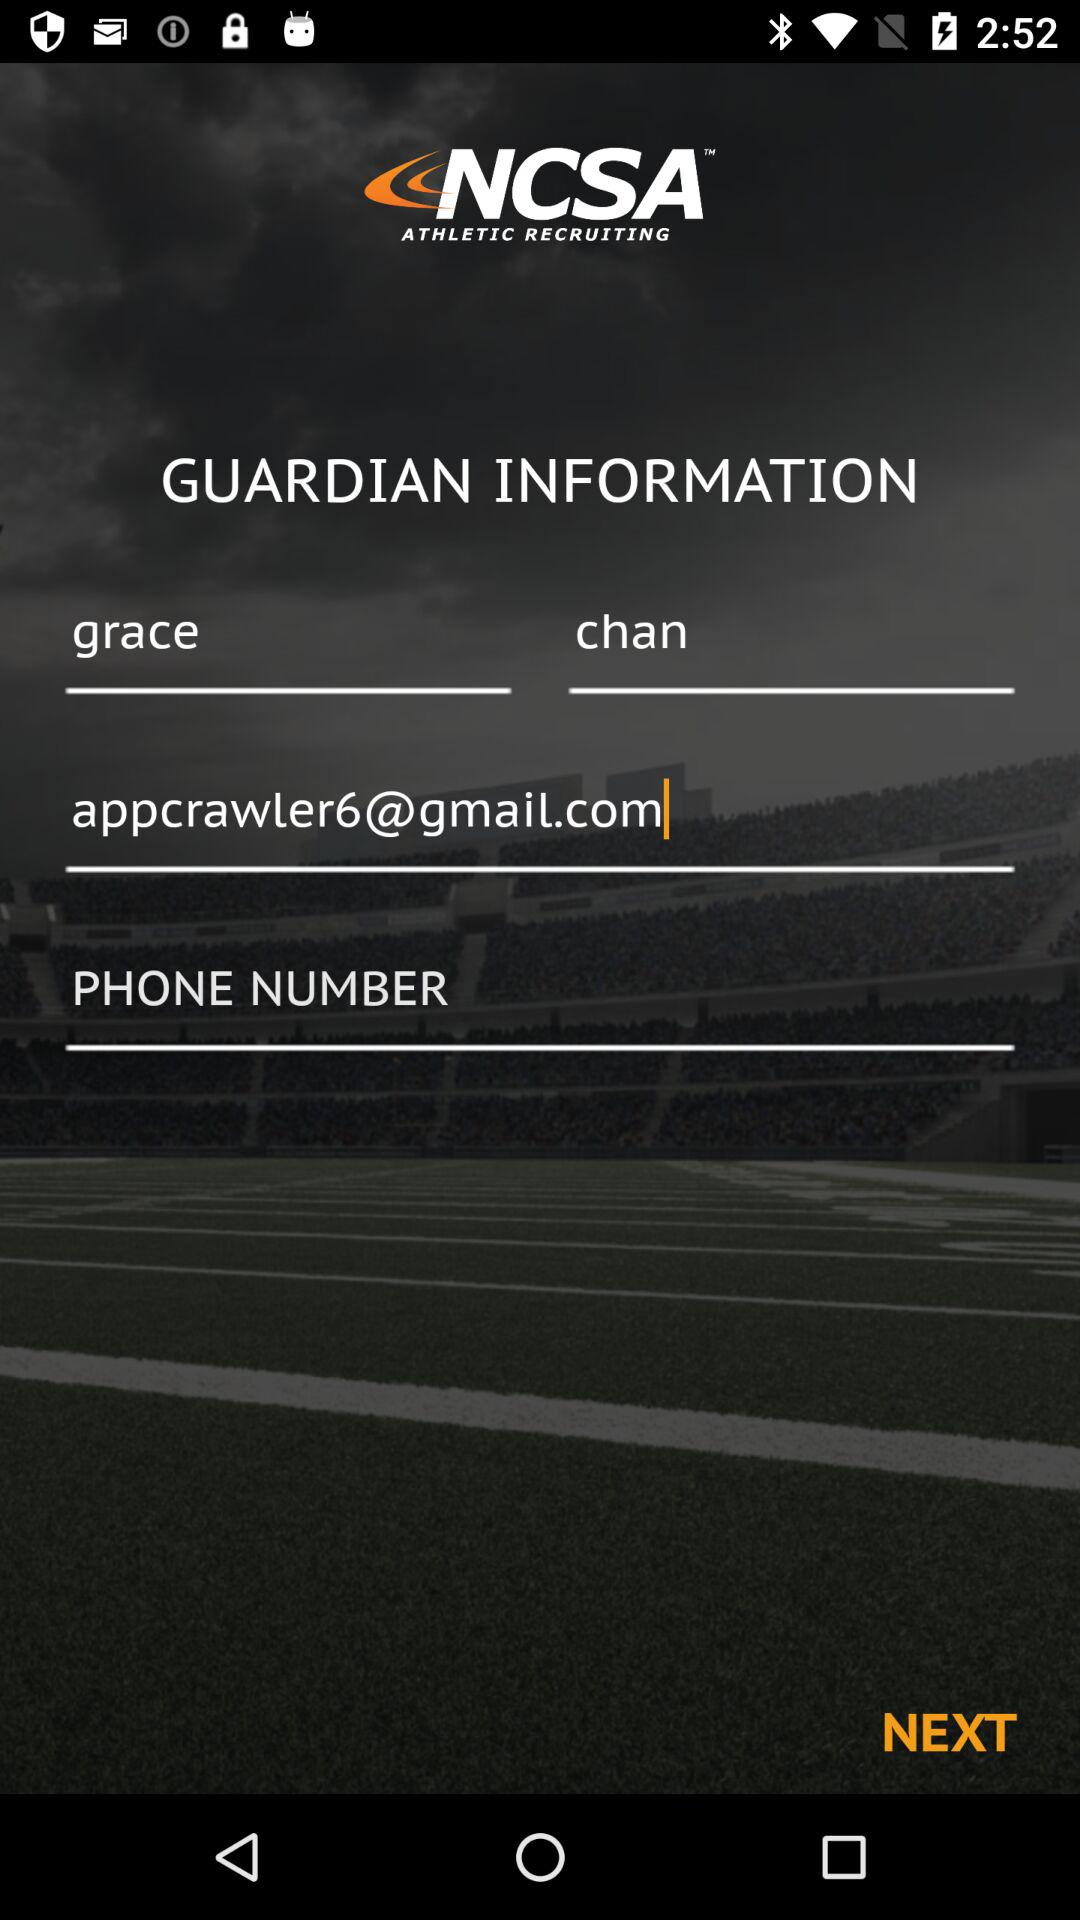What is the application name? The application name is "NCSA ATHLETIC RECRUITING". 